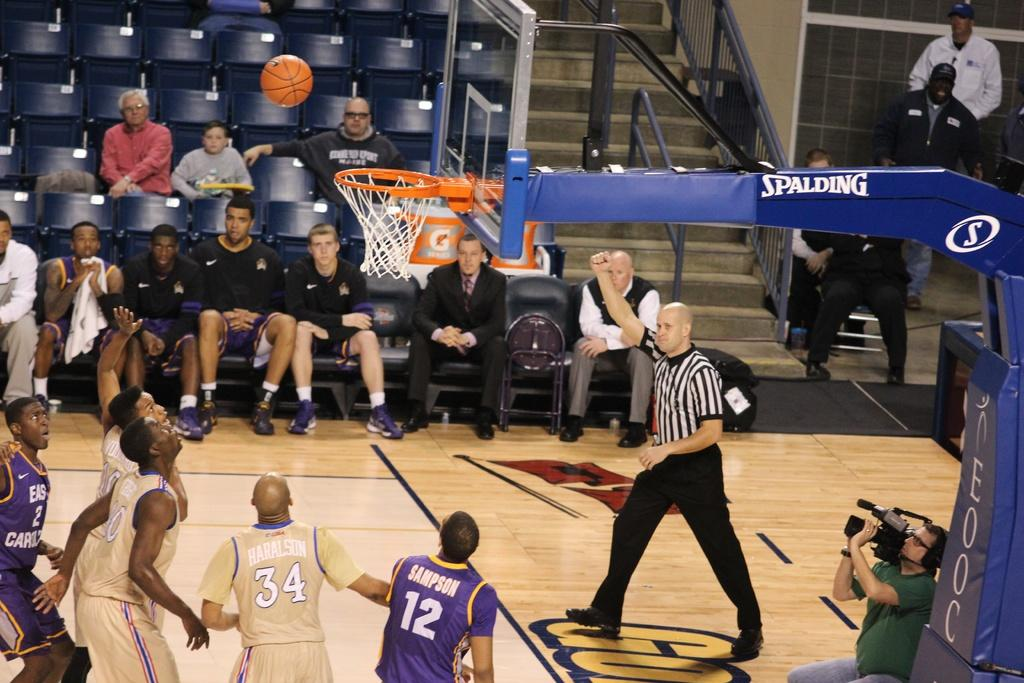<image>
Present a compact description of the photo's key features. A basketball hoop labeled Spalding hangs over a game in progress. 